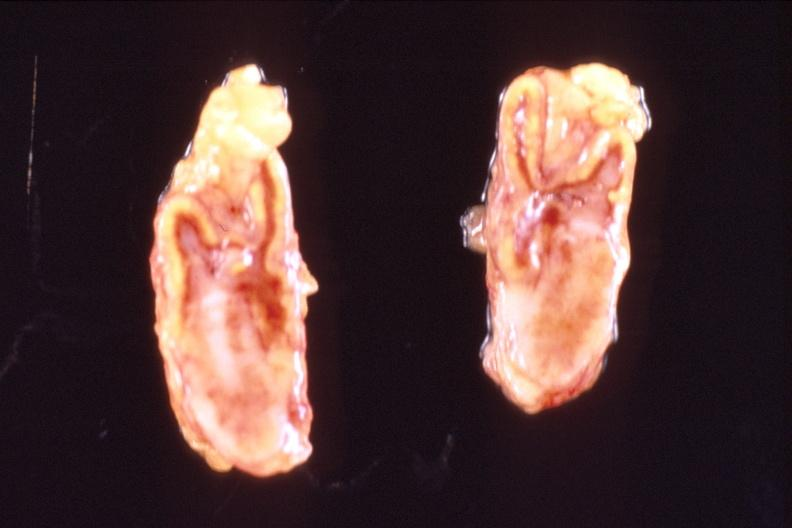s endocrine present?
Answer the question using a single word or phrase. Yes 